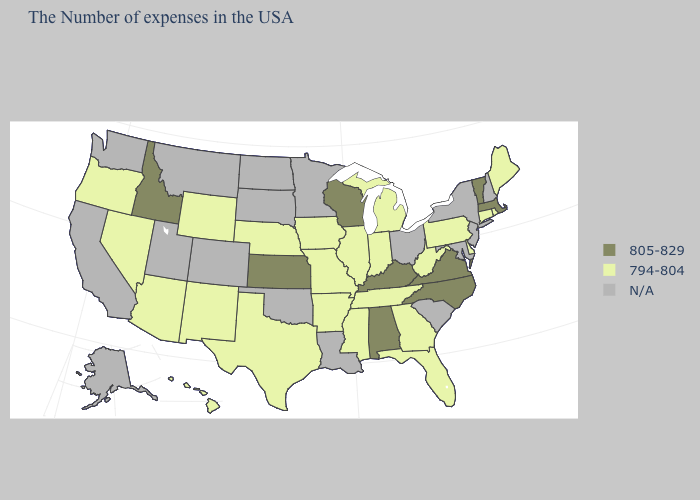Name the states that have a value in the range 794-804?
Short answer required. Maine, Rhode Island, Connecticut, Delaware, Pennsylvania, West Virginia, Florida, Georgia, Michigan, Indiana, Tennessee, Illinois, Mississippi, Missouri, Arkansas, Iowa, Nebraska, Texas, Wyoming, New Mexico, Arizona, Nevada, Oregon, Hawaii. Name the states that have a value in the range 805-829?
Short answer required. Massachusetts, Vermont, Virginia, North Carolina, Kentucky, Alabama, Wisconsin, Kansas, Idaho. What is the value of Maryland?
Keep it brief. N/A. Does Illinois have the highest value in the USA?
Quick response, please. No. Does Oregon have the lowest value in the West?
Give a very brief answer. Yes. What is the value of South Carolina?
Give a very brief answer. N/A. Does Kansas have the highest value in the MidWest?
Short answer required. Yes. Name the states that have a value in the range 805-829?
Be succinct. Massachusetts, Vermont, Virginia, North Carolina, Kentucky, Alabama, Wisconsin, Kansas, Idaho. Name the states that have a value in the range 805-829?
Quick response, please. Massachusetts, Vermont, Virginia, North Carolina, Kentucky, Alabama, Wisconsin, Kansas, Idaho. Does the first symbol in the legend represent the smallest category?
Write a very short answer. No. What is the value of New Jersey?
Short answer required. N/A. What is the value of Kentucky?
Be succinct. 805-829. Does Idaho have the lowest value in the USA?
Answer briefly. No. Name the states that have a value in the range N/A?
Keep it brief. New Hampshire, New York, New Jersey, Maryland, South Carolina, Ohio, Louisiana, Minnesota, Oklahoma, South Dakota, North Dakota, Colorado, Utah, Montana, California, Washington, Alaska. 